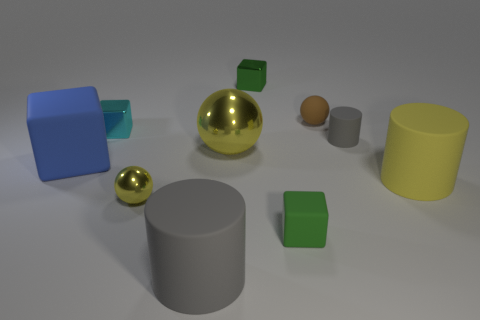Subtract all blue spheres. How many green blocks are left? 2 Subtract all small matte spheres. How many spheres are left? 2 Subtract 1 cylinders. How many cylinders are left? 2 Subtract all blue cubes. How many cubes are left? 3 Subtract all blocks. How many objects are left? 6 Subtract 0 purple cylinders. How many objects are left? 10 Subtract all green cubes. Subtract all cyan cylinders. How many cubes are left? 2 Subtract all blue blocks. Subtract all cyan things. How many objects are left? 8 Add 6 tiny yellow metal balls. How many tiny yellow metal balls are left? 7 Add 6 tiny red shiny cubes. How many tiny red shiny cubes exist? 6 